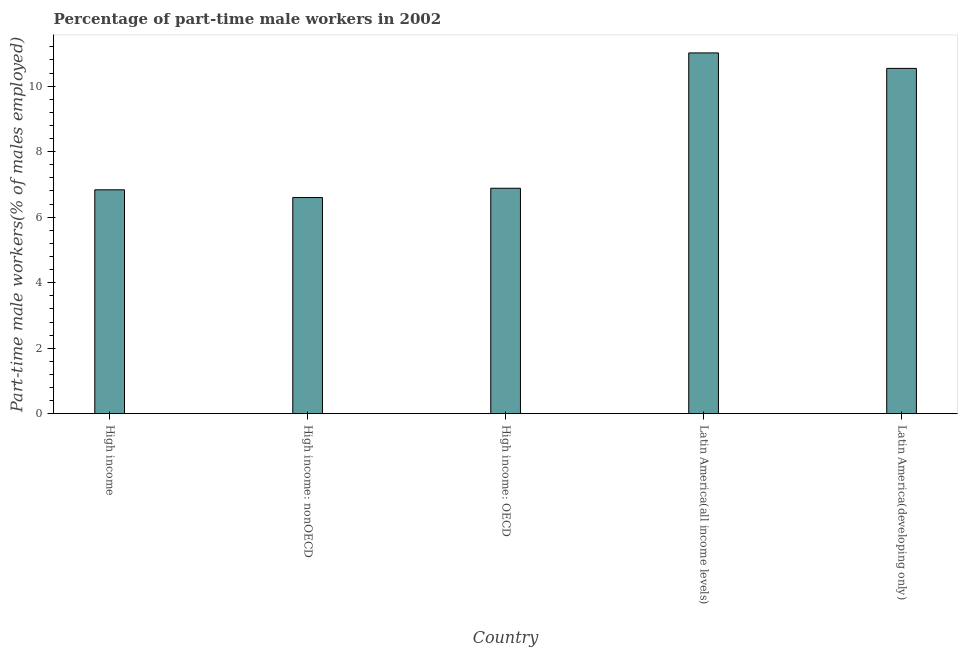Does the graph contain grids?
Provide a short and direct response. No. What is the title of the graph?
Provide a short and direct response. Percentage of part-time male workers in 2002. What is the label or title of the Y-axis?
Make the answer very short. Part-time male workers(% of males employed). What is the percentage of part-time male workers in High income: OECD?
Ensure brevity in your answer.  6.88. Across all countries, what is the maximum percentage of part-time male workers?
Your answer should be compact. 11.01. Across all countries, what is the minimum percentage of part-time male workers?
Keep it short and to the point. 6.6. In which country was the percentage of part-time male workers maximum?
Make the answer very short. Latin America(all income levels). In which country was the percentage of part-time male workers minimum?
Give a very brief answer. High income: nonOECD. What is the sum of the percentage of part-time male workers?
Give a very brief answer. 41.88. What is the difference between the percentage of part-time male workers in High income and High income: nonOECD?
Ensure brevity in your answer.  0.24. What is the average percentage of part-time male workers per country?
Give a very brief answer. 8.38. What is the median percentage of part-time male workers?
Your answer should be compact. 6.88. What is the ratio of the percentage of part-time male workers in High income: nonOECD to that in Latin America(all income levels)?
Ensure brevity in your answer.  0.6. Is the percentage of part-time male workers in High income: nonOECD less than that in Latin America(all income levels)?
Your answer should be very brief. Yes. Is the difference between the percentage of part-time male workers in High income and Latin America(all income levels) greater than the difference between any two countries?
Give a very brief answer. No. What is the difference between the highest and the second highest percentage of part-time male workers?
Provide a short and direct response. 0.47. Is the sum of the percentage of part-time male workers in High income: OECD and Latin America(developing only) greater than the maximum percentage of part-time male workers across all countries?
Your answer should be compact. Yes. What is the difference between the highest and the lowest percentage of part-time male workers?
Make the answer very short. 4.41. In how many countries, is the percentage of part-time male workers greater than the average percentage of part-time male workers taken over all countries?
Offer a very short reply. 2. How many bars are there?
Your answer should be compact. 5. How many countries are there in the graph?
Your answer should be very brief. 5. Are the values on the major ticks of Y-axis written in scientific E-notation?
Keep it short and to the point. No. What is the Part-time male workers(% of males employed) of High income?
Provide a short and direct response. 6.84. What is the Part-time male workers(% of males employed) in High income: nonOECD?
Offer a very short reply. 6.6. What is the Part-time male workers(% of males employed) of High income: OECD?
Your response must be concise. 6.88. What is the Part-time male workers(% of males employed) of Latin America(all income levels)?
Offer a very short reply. 11.01. What is the Part-time male workers(% of males employed) in Latin America(developing only)?
Your answer should be compact. 10.54. What is the difference between the Part-time male workers(% of males employed) in High income and High income: nonOECD?
Provide a short and direct response. 0.24. What is the difference between the Part-time male workers(% of males employed) in High income and High income: OECD?
Make the answer very short. -0.05. What is the difference between the Part-time male workers(% of males employed) in High income and Latin America(all income levels)?
Keep it short and to the point. -4.18. What is the difference between the Part-time male workers(% of males employed) in High income and Latin America(developing only)?
Your answer should be compact. -3.71. What is the difference between the Part-time male workers(% of males employed) in High income: nonOECD and High income: OECD?
Ensure brevity in your answer.  -0.28. What is the difference between the Part-time male workers(% of males employed) in High income: nonOECD and Latin America(all income levels)?
Your answer should be compact. -4.41. What is the difference between the Part-time male workers(% of males employed) in High income: nonOECD and Latin America(developing only)?
Keep it short and to the point. -3.94. What is the difference between the Part-time male workers(% of males employed) in High income: OECD and Latin America(all income levels)?
Give a very brief answer. -4.13. What is the difference between the Part-time male workers(% of males employed) in High income: OECD and Latin America(developing only)?
Offer a terse response. -3.66. What is the difference between the Part-time male workers(% of males employed) in Latin America(all income levels) and Latin America(developing only)?
Give a very brief answer. 0.47. What is the ratio of the Part-time male workers(% of males employed) in High income to that in High income: nonOECD?
Your response must be concise. 1.04. What is the ratio of the Part-time male workers(% of males employed) in High income to that in Latin America(all income levels)?
Offer a terse response. 0.62. What is the ratio of the Part-time male workers(% of males employed) in High income to that in Latin America(developing only)?
Offer a very short reply. 0.65. What is the ratio of the Part-time male workers(% of males employed) in High income: nonOECD to that in High income: OECD?
Ensure brevity in your answer.  0.96. What is the ratio of the Part-time male workers(% of males employed) in High income: nonOECD to that in Latin America(all income levels)?
Offer a very short reply. 0.6. What is the ratio of the Part-time male workers(% of males employed) in High income: nonOECD to that in Latin America(developing only)?
Your answer should be compact. 0.63. What is the ratio of the Part-time male workers(% of males employed) in High income: OECD to that in Latin America(all income levels)?
Offer a terse response. 0.62. What is the ratio of the Part-time male workers(% of males employed) in High income: OECD to that in Latin America(developing only)?
Provide a succinct answer. 0.65. What is the ratio of the Part-time male workers(% of males employed) in Latin America(all income levels) to that in Latin America(developing only)?
Offer a very short reply. 1.04. 